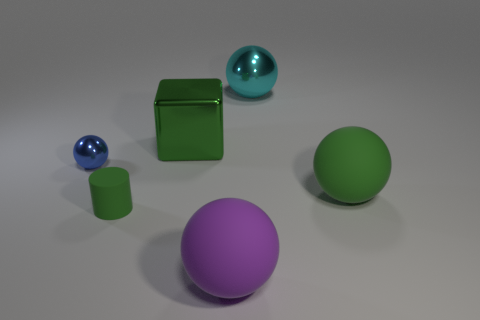Subtract all blue metal spheres. How many spheres are left? 3 Add 2 big cyan matte things. How many objects exist? 8 Subtract all blue spheres. How many spheres are left? 3 Subtract 3 balls. How many balls are left? 1 Subtract all red cylinders. Subtract all yellow blocks. How many cylinders are left? 1 Subtract all cyan blocks. How many blue balls are left? 1 Subtract all tiny green balls. Subtract all large green things. How many objects are left? 4 Add 3 large rubber objects. How many large rubber objects are left? 5 Add 1 tiny yellow shiny blocks. How many tiny yellow shiny blocks exist? 1 Subtract 1 green cylinders. How many objects are left? 5 